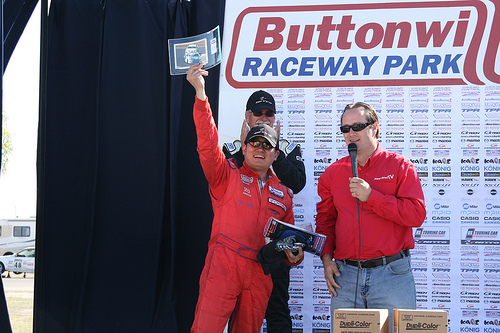<image>
Is the hat on the man? No. The hat is not positioned on the man. They may be near each other, but the hat is not supported by or resting on top of the man. 